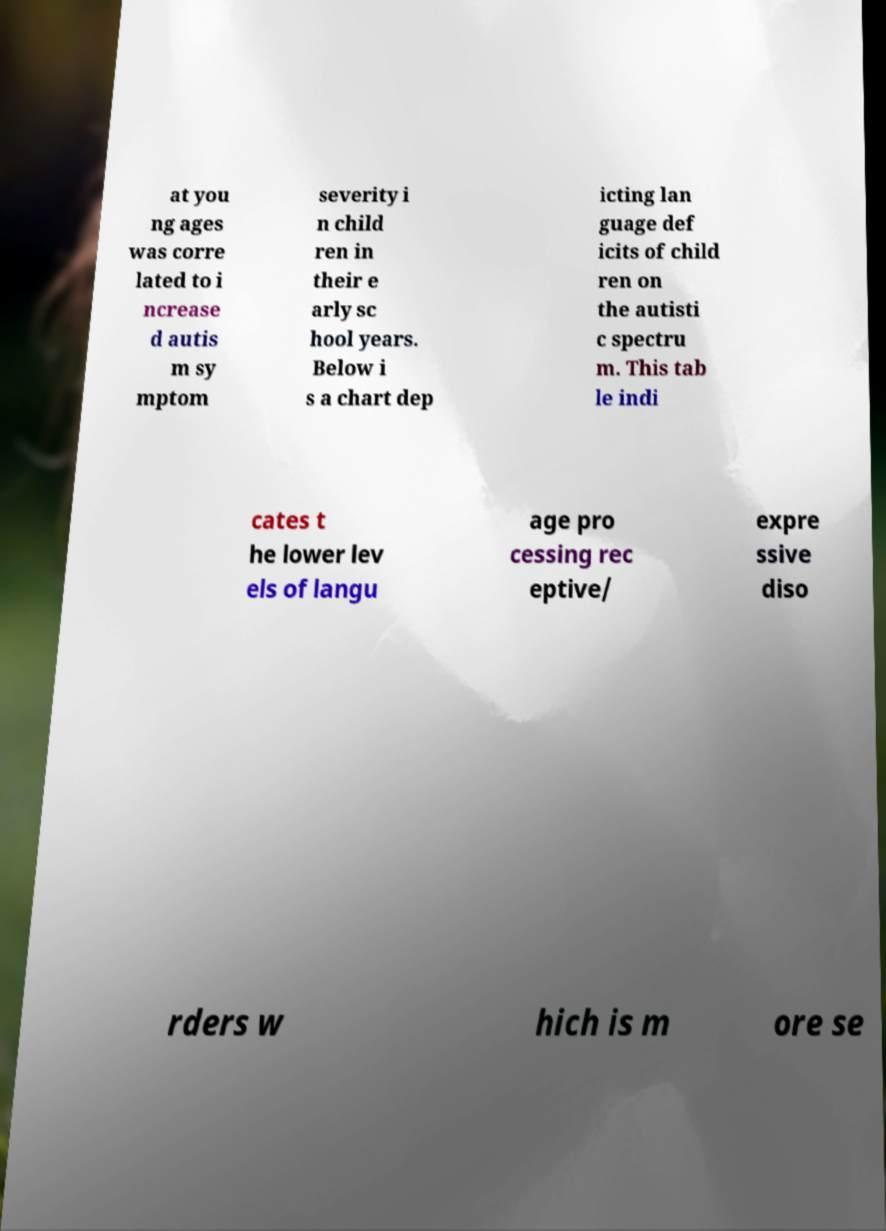Could you extract and type out the text from this image? at you ng ages was corre lated to i ncrease d autis m sy mptom severity i n child ren in their e arly sc hool years. Below i s a chart dep icting lan guage def icits of child ren on the autisti c spectru m. This tab le indi cates t he lower lev els of langu age pro cessing rec eptive/ expre ssive diso rders w hich is m ore se 